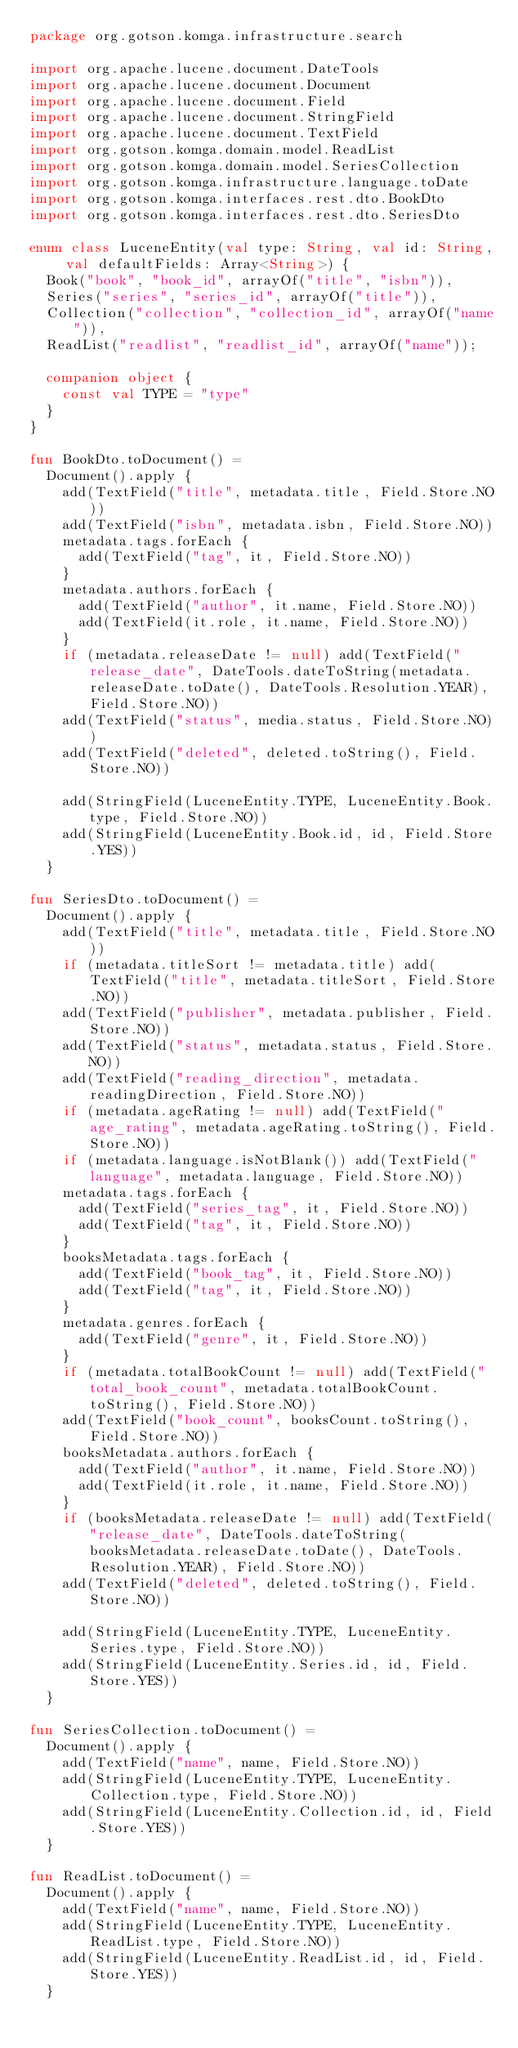Convert code to text. <code><loc_0><loc_0><loc_500><loc_500><_Kotlin_>package org.gotson.komga.infrastructure.search

import org.apache.lucene.document.DateTools
import org.apache.lucene.document.Document
import org.apache.lucene.document.Field
import org.apache.lucene.document.StringField
import org.apache.lucene.document.TextField
import org.gotson.komga.domain.model.ReadList
import org.gotson.komga.domain.model.SeriesCollection
import org.gotson.komga.infrastructure.language.toDate
import org.gotson.komga.interfaces.rest.dto.BookDto
import org.gotson.komga.interfaces.rest.dto.SeriesDto

enum class LuceneEntity(val type: String, val id: String, val defaultFields: Array<String>) {
  Book("book", "book_id", arrayOf("title", "isbn")),
  Series("series", "series_id", arrayOf("title")),
  Collection("collection", "collection_id", arrayOf("name")),
  ReadList("readlist", "readlist_id", arrayOf("name"));

  companion object {
    const val TYPE = "type"
  }
}

fun BookDto.toDocument() =
  Document().apply {
    add(TextField("title", metadata.title, Field.Store.NO))
    add(TextField("isbn", metadata.isbn, Field.Store.NO))
    metadata.tags.forEach {
      add(TextField("tag", it, Field.Store.NO))
    }
    metadata.authors.forEach {
      add(TextField("author", it.name, Field.Store.NO))
      add(TextField(it.role, it.name, Field.Store.NO))
    }
    if (metadata.releaseDate != null) add(TextField("release_date", DateTools.dateToString(metadata.releaseDate.toDate(), DateTools.Resolution.YEAR), Field.Store.NO))
    add(TextField("status", media.status, Field.Store.NO))
    add(TextField("deleted", deleted.toString(), Field.Store.NO))

    add(StringField(LuceneEntity.TYPE, LuceneEntity.Book.type, Field.Store.NO))
    add(StringField(LuceneEntity.Book.id, id, Field.Store.YES))
  }

fun SeriesDto.toDocument() =
  Document().apply {
    add(TextField("title", metadata.title, Field.Store.NO))
    if (metadata.titleSort != metadata.title) add(TextField("title", metadata.titleSort, Field.Store.NO))
    add(TextField("publisher", metadata.publisher, Field.Store.NO))
    add(TextField("status", metadata.status, Field.Store.NO))
    add(TextField("reading_direction", metadata.readingDirection, Field.Store.NO))
    if (metadata.ageRating != null) add(TextField("age_rating", metadata.ageRating.toString(), Field.Store.NO))
    if (metadata.language.isNotBlank()) add(TextField("language", metadata.language, Field.Store.NO))
    metadata.tags.forEach {
      add(TextField("series_tag", it, Field.Store.NO))
      add(TextField("tag", it, Field.Store.NO))
    }
    booksMetadata.tags.forEach {
      add(TextField("book_tag", it, Field.Store.NO))
      add(TextField("tag", it, Field.Store.NO))
    }
    metadata.genres.forEach {
      add(TextField("genre", it, Field.Store.NO))
    }
    if (metadata.totalBookCount != null) add(TextField("total_book_count", metadata.totalBookCount.toString(), Field.Store.NO))
    add(TextField("book_count", booksCount.toString(), Field.Store.NO))
    booksMetadata.authors.forEach {
      add(TextField("author", it.name, Field.Store.NO))
      add(TextField(it.role, it.name, Field.Store.NO))
    }
    if (booksMetadata.releaseDate != null) add(TextField("release_date", DateTools.dateToString(booksMetadata.releaseDate.toDate(), DateTools.Resolution.YEAR), Field.Store.NO))
    add(TextField("deleted", deleted.toString(), Field.Store.NO))

    add(StringField(LuceneEntity.TYPE, LuceneEntity.Series.type, Field.Store.NO))
    add(StringField(LuceneEntity.Series.id, id, Field.Store.YES))
  }

fun SeriesCollection.toDocument() =
  Document().apply {
    add(TextField("name", name, Field.Store.NO))
    add(StringField(LuceneEntity.TYPE, LuceneEntity.Collection.type, Field.Store.NO))
    add(StringField(LuceneEntity.Collection.id, id, Field.Store.YES))
  }

fun ReadList.toDocument() =
  Document().apply {
    add(TextField("name", name, Field.Store.NO))
    add(StringField(LuceneEntity.TYPE, LuceneEntity.ReadList.type, Field.Store.NO))
    add(StringField(LuceneEntity.ReadList.id, id, Field.Store.YES))
  }
</code> 